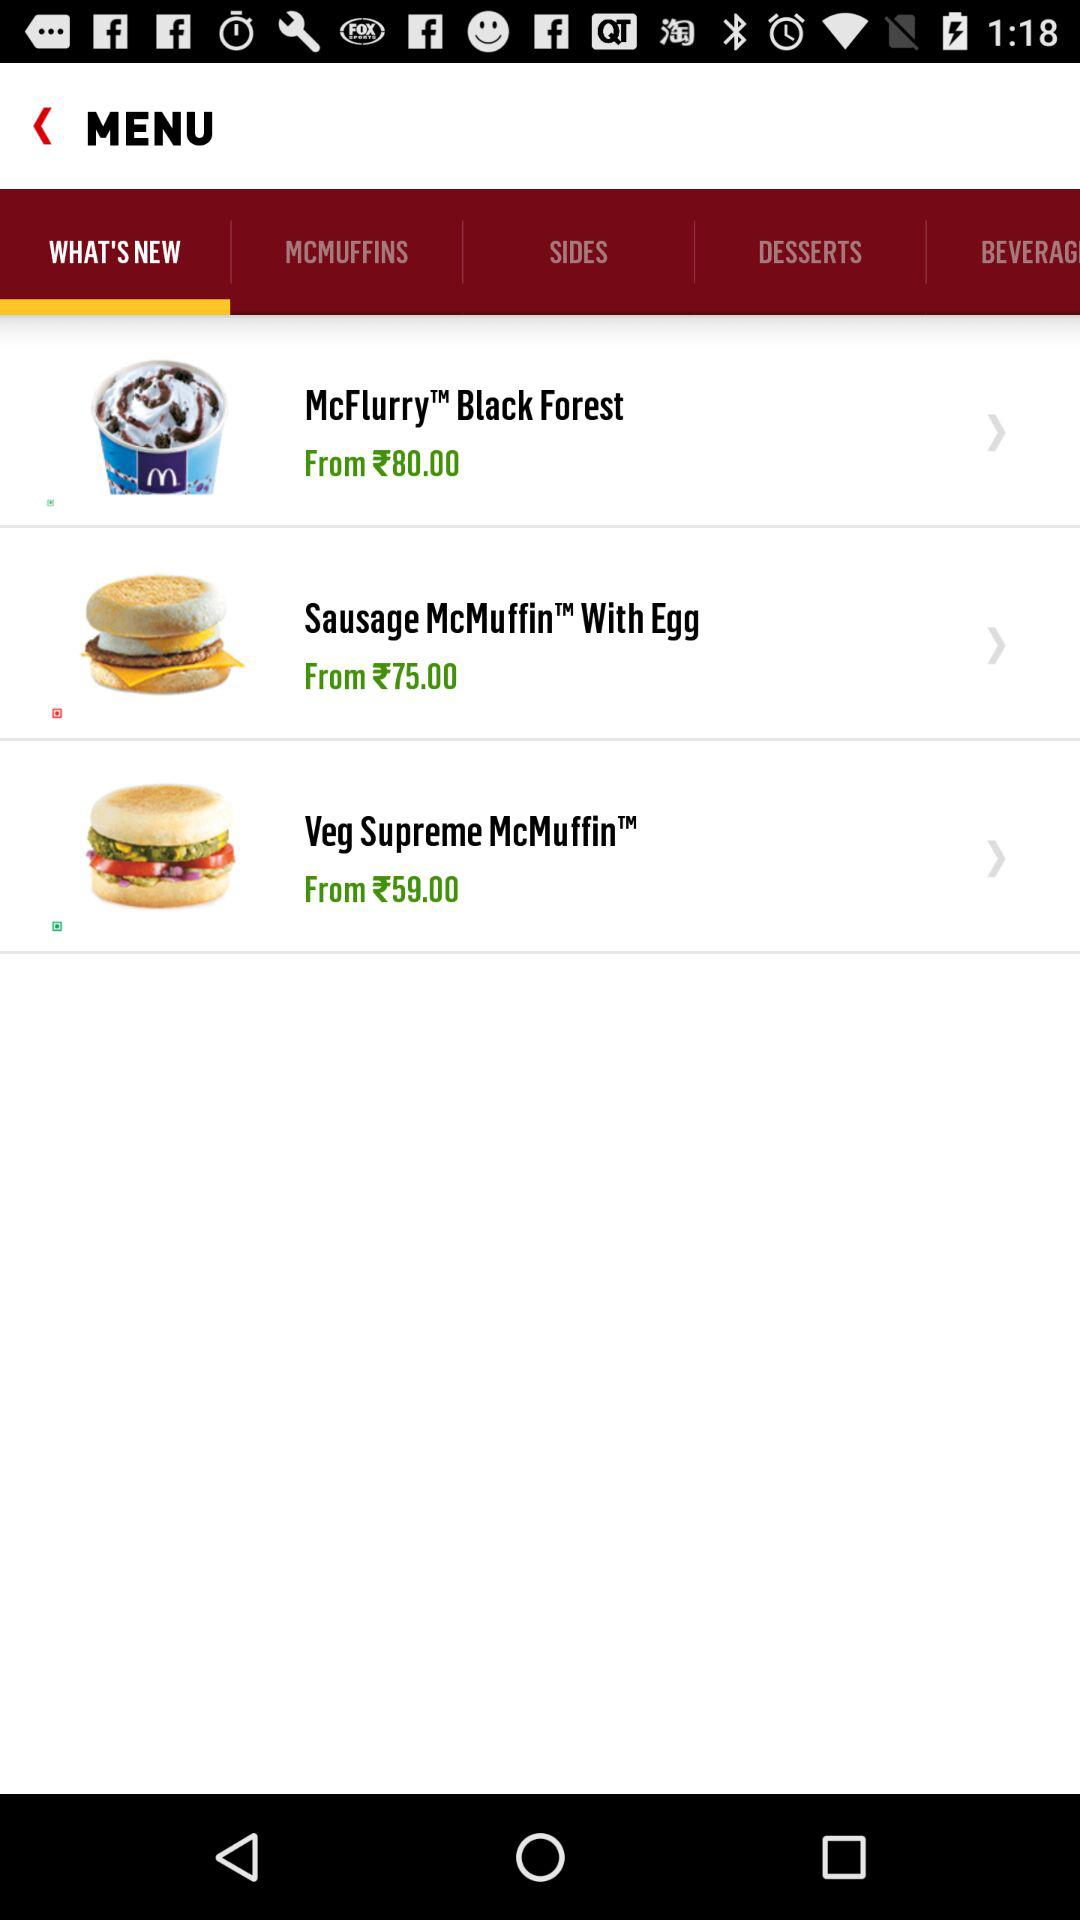What is the price of "McFlurry Black Forest"? The price of "McFlurry Black Forest" starts at ₹80. 